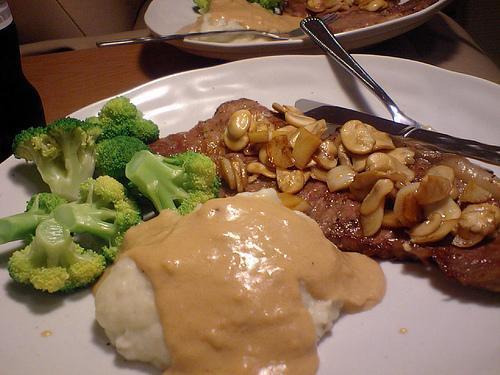How many plates are there?
Give a very brief answer. 2. How many knives can you see?
Give a very brief answer. 1. 